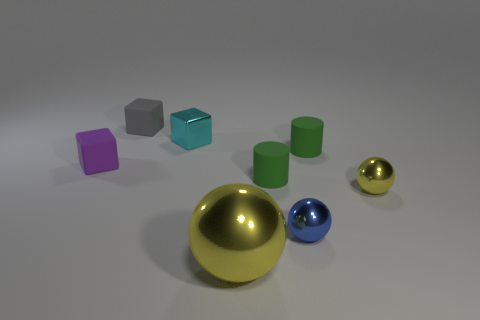What number of spheres are either small yellow objects or large yellow metal objects?
Keep it short and to the point. 2. Is the number of blue things that are in front of the tiny blue object the same as the number of large gray matte balls?
Provide a short and direct response. Yes. What is the green thing that is behind the small matte cube that is in front of the rubber cube that is behind the tiny cyan block made of?
Your response must be concise. Rubber. What is the material of the other thing that is the same color as the large object?
Your answer should be very brief. Metal. What number of things are either yellow metallic objects behind the tiny blue metal sphere or purple matte blocks?
Give a very brief answer. 2. What number of things are tiny yellow things or matte things that are to the right of the large yellow metal thing?
Give a very brief answer. 3. How many small cyan cubes are on the left side of the block left of the small matte block that is on the right side of the purple matte thing?
Keep it short and to the point. 0. There is a purple thing that is the same size as the gray rubber thing; what is its material?
Provide a short and direct response. Rubber. Is there a red thing that has the same size as the cyan object?
Your answer should be very brief. No. What color is the big sphere?
Offer a very short reply. Yellow. 